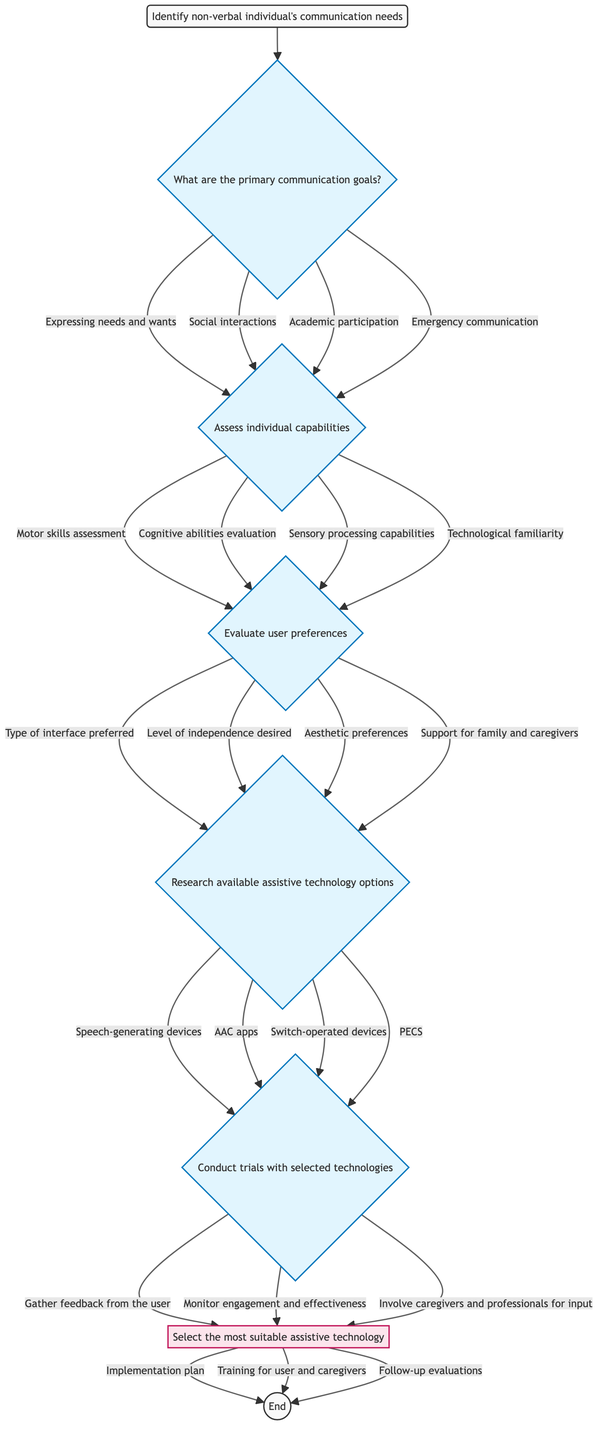What is the first step in the decision-making pathway? The diagram begins with "Identify non-verbal individual's communication needs," indicating the first and initial step before any other actions.
Answer: Identify non-verbal individual's communication needs How many primary communication goals are listed? In the diagram, there are four listed primary communication goals branching from the first question, which can be counted easily from the options provided.
Answer: 4 Which step assesses "Motor skills"? The flow specifically indicates that "Motor skills assessment" is part of Step 2, where individual capabilities are assessed before moving on to evaluating user preferences.
Answer: Step 2 What types of technologies are researched in Step 4? The diagram lists four options for available assistive technology to be researched, directly accessible from Step 4 as the next action following user preferences.
Answer: Speech-generating devices, AAC apps, Switch-operated devices, PECS What is the outcome of conducting trials with selected technologies? The diagram leads to a decision node after trials, culminating in the selection of the most suitable assistive technology as the outcome of that section.
Answer: Select the most suitable assistive technology Which step involves gathering feedback from the user? "Gather feedback from the user" is explicitly mentioned as an option under Step 5, where trials with selected technologies take place, pointing to its importance in evaluating effectiveness.
Answer: Step 5 What are the next steps after selecting assistive technology? Following the decision node, the diagram indicates three next steps that branch out, showcasing the planned actions after selection.
Answer: Implementation plan, Training for user and caregivers, Follow-up evaluations How is "Cognitive abilities evaluation" related to user capabilities? The diagram shows "Cognitive abilities evaluation" is part of Step 2, which assesses individual capabilities before progressing to user preferences, highlighting its role in understanding the user's ability to communicate.
Answer: Step 2 Which interface type is mentioned in the user preferences evaluation? The options in Step 3 specifically include "Type of interface preferred," indicating a direct focus on the user's preferred method of interaction.
Answer: Type of interface preferred 